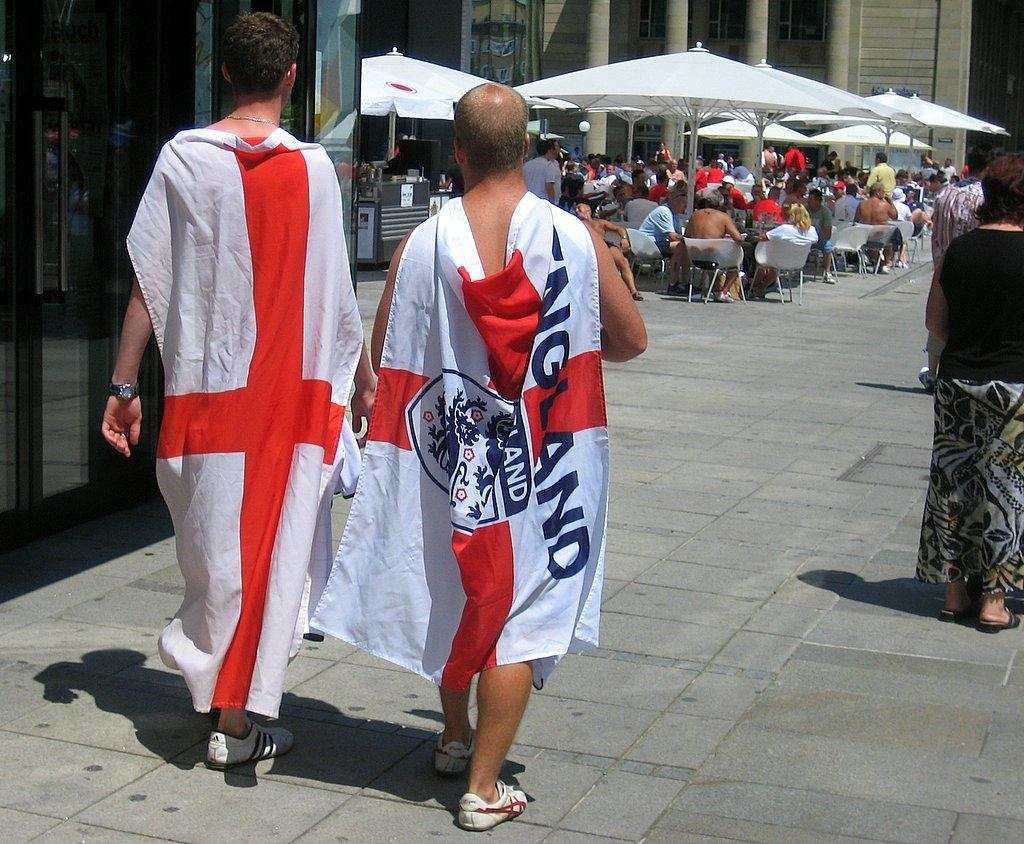Provide a one-sentence caption for the provided image. Two mane walking toward some table wearing only a England flag. 